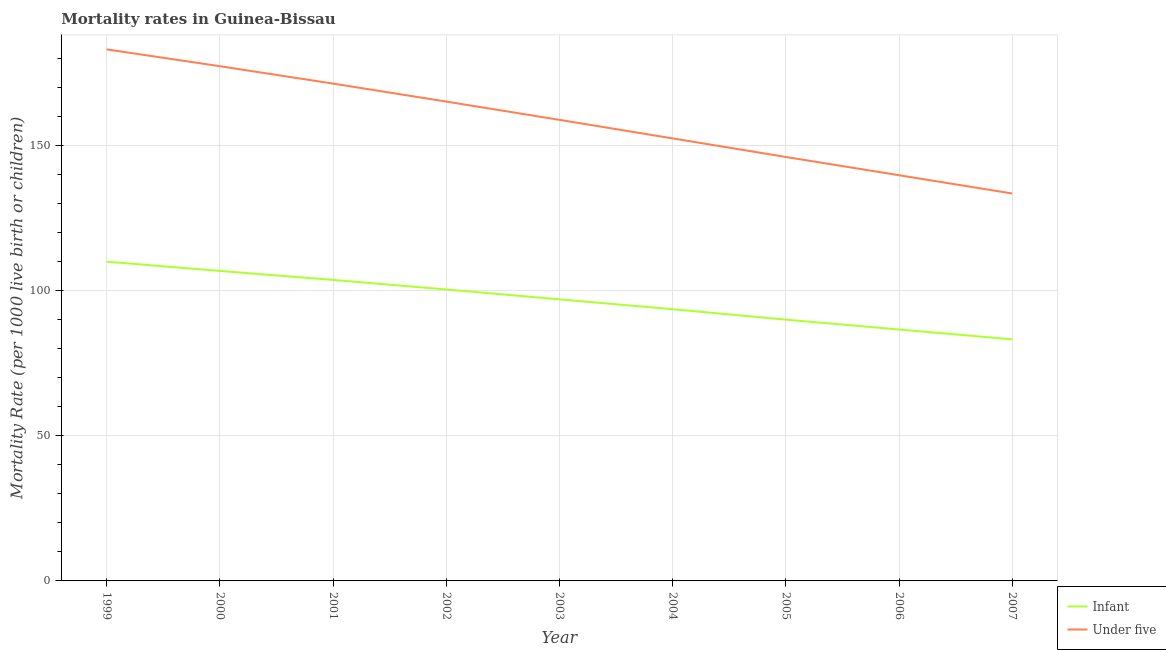How many different coloured lines are there?
Offer a very short reply. 2. Is the number of lines equal to the number of legend labels?
Your answer should be compact. Yes. What is the under-5 mortality rate in 2005?
Ensure brevity in your answer.  146.2. Across all years, what is the maximum under-5 mortality rate?
Give a very brief answer. 183.3. Across all years, what is the minimum infant mortality rate?
Your response must be concise. 83.3. In which year was the infant mortality rate maximum?
Provide a succinct answer. 1999. What is the total under-5 mortality rate in the graph?
Offer a terse response. 1428.9. What is the difference between the under-5 mortality rate in 2002 and that in 2006?
Offer a terse response. 25.4. What is the difference between the under-5 mortality rate in 2003 and the infant mortality rate in 2007?
Offer a terse response. 75.7. What is the average under-5 mortality rate per year?
Ensure brevity in your answer.  158.77. In the year 2002, what is the difference between the infant mortality rate and under-5 mortality rate?
Provide a short and direct response. -64.8. In how many years, is the under-5 mortality rate greater than 160?
Your answer should be compact. 4. What is the ratio of the infant mortality rate in 2001 to that in 2005?
Your answer should be very brief. 1.15. Is the infant mortality rate in 1999 less than that in 2004?
Offer a very short reply. No. What is the difference between the highest and the second highest under-5 mortality rate?
Ensure brevity in your answer.  5.8. What is the difference between the highest and the lowest infant mortality rate?
Keep it short and to the point. 26.8. In how many years, is the under-5 mortality rate greater than the average under-5 mortality rate taken over all years?
Your answer should be compact. 5. Is the sum of the under-5 mortality rate in 1999 and 2003 greater than the maximum infant mortality rate across all years?
Offer a terse response. Yes. Does the infant mortality rate monotonically increase over the years?
Give a very brief answer. No. Is the infant mortality rate strictly less than the under-5 mortality rate over the years?
Your answer should be very brief. Yes. Are the values on the major ticks of Y-axis written in scientific E-notation?
Your answer should be very brief. No. Does the graph contain any zero values?
Offer a terse response. No. Does the graph contain grids?
Make the answer very short. Yes. How many legend labels are there?
Offer a very short reply. 2. What is the title of the graph?
Provide a succinct answer. Mortality rates in Guinea-Bissau. Does "Pregnant women" appear as one of the legend labels in the graph?
Offer a terse response. No. What is the label or title of the Y-axis?
Your answer should be compact. Mortality Rate (per 1000 live birth or children). What is the Mortality Rate (per 1000 live birth or children) of Infant in 1999?
Ensure brevity in your answer.  110.1. What is the Mortality Rate (per 1000 live birth or children) of Under five in 1999?
Ensure brevity in your answer.  183.3. What is the Mortality Rate (per 1000 live birth or children) in Infant in 2000?
Provide a succinct answer. 106.9. What is the Mortality Rate (per 1000 live birth or children) of Under five in 2000?
Make the answer very short. 177.5. What is the Mortality Rate (per 1000 live birth or children) in Infant in 2001?
Offer a very short reply. 103.8. What is the Mortality Rate (per 1000 live birth or children) of Under five in 2001?
Your answer should be compact. 171.5. What is the Mortality Rate (per 1000 live birth or children) of Infant in 2002?
Give a very brief answer. 100.5. What is the Mortality Rate (per 1000 live birth or children) of Under five in 2002?
Your answer should be compact. 165.3. What is the Mortality Rate (per 1000 live birth or children) of Infant in 2003?
Ensure brevity in your answer.  97.1. What is the Mortality Rate (per 1000 live birth or children) in Under five in 2003?
Provide a succinct answer. 159. What is the Mortality Rate (per 1000 live birth or children) of Infant in 2004?
Make the answer very short. 93.7. What is the Mortality Rate (per 1000 live birth or children) in Under five in 2004?
Your response must be concise. 152.6. What is the Mortality Rate (per 1000 live birth or children) of Infant in 2005?
Your answer should be very brief. 90.1. What is the Mortality Rate (per 1000 live birth or children) of Under five in 2005?
Provide a succinct answer. 146.2. What is the Mortality Rate (per 1000 live birth or children) of Infant in 2006?
Make the answer very short. 86.7. What is the Mortality Rate (per 1000 live birth or children) in Under five in 2006?
Offer a terse response. 139.9. What is the Mortality Rate (per 1000 live birth or children) of Infant in 2007?
Offer a terse response. 83.3. What is the Mortality Rate (per 1000 live birth or children) of Under five in 2007?
Make the answer very short. 133.6. Across all years, what is the maximum Mortality Rate (per 1000 live birth or children) in Infant?
Give a very brief answer. 110.1. Across all years, what is the maximum Mortality Rate (per 1000 live birth or children) of Under five?
Your response must be concise. 183.3. Across all years, what is the minimum Mortality Rate (per 1000 live birth or children) in Infant?
Your answer should be compact. 83.3. Across all years, what is the minimum Mortality Rate (per 1000 live birth or children) of Under five?
Offer a very short reply. 133.6. What is the total Mortality Rate (per 1000 live birth or children) in Infant in the graph?
Your answer should be compact. 872.2. What is the total Mortality Rate (per 1000 live birth or children) of Under five in the graph?
Your answer should be very brief. 1428.9. What is the difference between the Mortality Rate (per 1000 live birth or children) in Under five in 1999 and that in 2000?
Your answer should be compact. 5.8. What is the difference between the Mortality Rate (per 1000 live birth or children) in Under five in 1999 and that in 2001?
Provide a succinct answer. 11.8. What is the difference between the Mortality Rate (per 1000 live birth or children) in Under five in 1999 and that in 2003?
Your response must be concise. 24.3. What is the difference between the Mortality Rate (per 1000 live birth or children) in Infant in 1999 and that in 2004?
Provide a short and direct response. 16.4. What is the difference between the Mortality Rate (per 1000 live birth or children) in Under five in 1999 and that in 2004?
Keep it short and to the point. 30.7. What is the difference between the Mortality Rate (per 1000 live birth or children) in Under five in 1999 and that in 2005?
Provide a short and direct response. 37.1. What is the difference between the Mortality Rate (per 1000 live birth or children) of Infant in 1999 and that in 2006?
Ensure brevity in your answer.  23.4. What is the difference between the Mortality Rate (per 1000 live birth or children) of Under five in 1999 and that in 2006?
Provide a short and direct response. 43.4. What is the difference between the Mortality Rate (per 1000 live birth or children) of Infant in 1999 and that in 2007?
Your answer should be very brief. 26.8. What is the difference between the Mortality Rate (per 1000 live birth or children) in Under five in 1999 and that in 2007?
Offer a terse response. 49.7. What is the difference between the Mortality Rate (per 1000 live birth or children) of Under five in 2000 and that in 2001?
Offer a very short reply. 6. What is the difference between the Mortality Rate (per 1000 live birth or children) of Infant in 2000 and that in 2003?
Offer a terse response. 9.8. What is the difference between the Mortality Rate (per 1000 live birth or children) in Infant in 2000 and that in 2004?
Keep it short and to the point. 13.2. What is the difference between the Mortality Rate (per 1000 live birth or children) of Under five in 2000 and that in 2004?
Give a very brief answer. 24.9. What is the difference between the Mortality Rate (per 1000 live birth or children) of Infant in 2000 and that in 2005?
Ensure brevity in your answer.  16.8. What is the difference between the Mortality Rate (per 1000 live birth or children) in Under five in 2000 and that in 2005?
Your response must be concise. 31.3. What is the difference between the Mortality Rate (per 1000 live birth or children) in Infant in 2000 and that in 2006?
Offer a very short reply. 20.2. What is the difference between the Mortality Rate (per 1000 live birth or children) in Under five in 2000 and that in 2006?
Give a very brief answer. 37.6. What is the difference between the Mortality Rate (per 1000 live birth or children) of Infant in 2000 and that in 2007?
Provide a short and direct response. 23.6. What is the difference between the Mortality Rate (per 1000 live birth or children) of Under five in 2000 and that in 2007?
Keep it short and to the point. 43.9. What is the difference between the Mortality Rate (per 1000 live birth or children) of Under five in 2001 and that in 2002?
Your answer should be very brief. 6.2. What is the difference between the Mortality Rate (per 1000 live birth or children) in Infant in 2001 and that in 2003?
Provide a succinct answer. 6.7. What is the difference between the Mortality Rate (per 1000 live birth or children) of Under five in 2001 and that in 2004?
Keep it short and to the point. 18.9. What is the difference between the Mortality Rate (per 1000 live birth or children) of Infant in 2001 and that in 2005?
Offer a very short reply. 13.7. What is the difference between the Mortality Rate (per 1000 live birth or children) of Under five in 2001 and that in 2005?
Your answer should be very brief. 25.3. What is the difference between the Mortality Rate (per 1000 live birth or children) in Under five in 2001 and that in 2006?
Your answer should be very brief. 31.6. What is the difference between the Mortality Rate (per 1000 live birth or children) of Under five in 2001 and that in 2007?
Ensure brevity in your answer.  37.9. What is the difference between the Mortality Rate (per 1000 live birth or children) of Infant in 2002 and that in 2003?
Your answer should be very brief. 3.4. What is the difference between the Mortality Rate (per 1000 live birth or children) in Under five in 2002 and that in 2003?
Your response must be concise. 6.3. What is the difference between the Mortality Rate (per 1000 live birth or children) in Under five in 2002 and that in 2005?
Provide a succinct answer. 19.1. What is the difference between the Mortality Rate (per 1000 live birth or children) in Under five in 2002 and that in 2006?
Keep it short and to the point. 25.4. What is the difference between the Mortality Rate (per 1000 live birth or children) of Infant in 2002 and that in 2007?
Your answer should be compact. 17.2. What is the difference between the Mortality Rate (per 1000 live birth or children) of Under five in 2002 and that in 2007?
Provide a succinct answer. 31.7. What is the difference between the Mortality Rate (per 1000 live birth or children) of Under five in 2003 and that in 2004?
Your response must be concise. 6.4. What is the difference between the Mortality Rate (per 1000 live birth or children) of Infant in 2003 and that in 2005?
Keep it short and to the point. 7. What is the difference between the Mortality Rate (per 1000 live birth or children) in Under five in 2003 and that in 2005?
Give a very brief answer. 12.8. What is the difference between the Mortality Rate (per 1000 live birth or children) of Infant in 2003 and that in 2006?
Make the answer very short. 10.4. What is the difference between the Mortality Rate (per 1000 live birth or children) of Infant in 2003 and that in 2007?
Offer a very short reply. 13.8. What is the difference between the Mortality Rate (per 1000 live birth or children) of Under five in 2003 and that in 2007?
Ensure brevity in your answer.  25.4. What is the difference between the Mortality Rate (per 1000 live birth or children) in Under five in 2004 and that in 2005?
Make the answer very short. 6.4. What is the difference between the Mortality Rate (per 1000 live birth or children) of Infant in 2004 and that in 2006?
Keep it short and to the point. 7. What is the difference between the Mortality Rate (per 1000 live birth or children) in Under five in 2004 and that in 2006?
Keep it short and to the point. 12.7. What is the difference between the Mortality Rate (per 1000 live birth or children) of Infant in 2004 and that in 2007?
Ensure brevity in your answer.  10.4. What is the difference between the Mortality Rate (per 1000 live birth or children) in Under five in 2006 and that in 2007?
Provide a short and direct response. 6.3. What is the difference between the Mortality Rate (per 1000 live birth or children) in Infant in 1999 and the Mortality Rate (per 1000 live birth or children) in Under five in 2000?
Your response must be concise. -67.4. What is the difference between the Mortality Rate (per 1000 live birth or children) of Infant in 1999 and the Mortality Rate (per 1000 live birth or children) of Under five in 2001?
Provide a succinct answer. -61.4. What is the difference between the Mortality Rate (per 1000 live birth or children) of Infant in 1999 and the Mortality Rate (per 1000 live birth or children) of Under five in 2002?
Provide a short and direct response. -55.2. What is the difference between the Mortality Rate (per 1000 live birth or children) of Infant in 1999 and the Mortality Rate (per 1000 live birth or children) of Under five in 2003?
Ensure brevity in your answer.  -48.9. What is the difference between the Mortality Rate (per 1000 live birth or children) in Infant in 1999 and the Mortality Rate (per 1000 live birth or children) in Under five in 2004?
Offer a terse response. -42.5. What is the difference between the Mortality Rate (per 1000 live birth or children) of Infant in 1999 and the Mortality Rate (per 1000 live birth or children) of Under five in 2005?
Provide a short and direct response. -36.1. What is the difference between the Mortality Rate (per 1000 live birth or children) of Infant in 1999 and the Mortality Rate (per 1000 live birth or children) of Under five in 2006?
Keep it short and to the point. -29.8. What is the difference between the Mortality Rate (per 1000 live birth or children) of Infant in 1999 and the Mortality Rate (per 1000 live birth or children) of Under five in 2007?
Offer a very short reply. -23.5. What is the difference between the Mortality Rate (per 1000 live birth or children) in Infant in 2000 and the Mortality Rate (per 1000 live birth or children) in Under five in 2001?
Your response must be concise. -64.6. What is the difference between the Mortality Rate (per 1000 live birth or children) of Infant in 2000 and the Mortality Rate (per 1000 live birth or children) of Under five in 2002?
Your answer should be very brief. -58.4. What is the difference between the Mortality Rate (per 1000 live birth or children) in Infant in 2000 and the Mortality Rate (per 1000 live birth or children) in Under five in 2003?
Provide a succinct answer. -52.1. What is the difference between the Mortality Rate (per 1000 live birth or children) in Infant in 2000 and the Mortality Rate (per 1000 live birth or children) in Under five in 2004?
Your response must be concise. -45.7. What is the difference between the Mortality Rate (per 1000 live birth or children) of Infant in 2000 and the Mortality Rate (per 1000 live birth or children) of Under five in 2005?
Your answer should be very brief. -39.3. What is the difference between the Mortality Rate (per 1000 live birth or children) of Infant in 2000 and the Mortality Rate (per 1000 live birth or children) of Under five in 2006?
Your response must be concise. -33. What is the difference between the Mortality Rate (per 1000 live birth or children) of Infant in 2000 and the Mortality Rate (per 1000 live birth or children) of Under five in 2007?
Ensure brevity in your answer.  -26.7. What is the difference between the Mortality Rate (per 1000 live birth or children) of Infant in 2001 and the Mortality Rate (per 1000 live birth or children) of Under five in 2002?
Ensure brevity in your answer.  -61.5. What is the difference between the Mortality Rate (per 1000 live birth or children) in Infant in 2001 and the Mortality Rate (per 1000 live birth or children) in Under five in 2003?
Ensure brevity in your answer.  -55.2. What is the difference between the Mortality Rate (per 1000 live birth or children) of Infant in 2001 and the Mortality Rate (per 1000 live birth or children) of Under five in 2004?
Keep it short and to the point. -48.8. What is the difference between the Mortality Rate (per 1000 live birth or children) of Infant in 2001 and the Mortality Rate (per 1000 live birth or children) of Under five in 2005?
Your answer should be compact. -42.4. What is the difference between the Mortality Rate (per 1000 live birth or children) in Infant in 2001 and the Mortality Rate (per 1000 live birth or children) in Under five in 2006?
Your answer should be compact. -36.1. What is the difference between the Mortality Rate (per 1000 live birth or children) in Infant in 2001 and the Mortality Rate (per 1000 live birth or children) in Under five in 2007?
Offer a very short reply. -29.8. What is the difference between the Mortality Rate (per 1000 live birth or children) of Infant in 2002 and the Mortality Rate (per 1000 live birth or children) of Under five in 2003?
Offer a terse response. -58.5. What is the difference between the Mortality Rate (per 1000 live birth or children) of Infant in 2002 and the Mortality Rate (per 1000 live birth or children) of Under five in 2004?
Keep it short and to the point. -52.1. What is the difference between the Mortality Rate (per 1000 live birth or children) of Infant in 2002 and the Mortality Rate (per 1000 live birth or children) of Under five in 2005?
Keep it short and to the point. -45.7. What is the difference between the Mortality Rate (per 1000 live birth or children) in Infant in 2002 and the Mortality Rate (per 1000 live birth or children) in Under five in 2006?
Provide a succinct answer. -39.4. What is the difference between the Mortality Rate (per 1000 live birth or children) in Infant in 2002 and the Mortality Rate (per 1000 live birth or children) in Under five in 2007?
Offer a very short reply. -33.1. What is the difference between the Mortality Rate (per 1000 live birth or children) in Infant in 2003 and the Mortality Rate (per 1000 live birth or children) in Under five in 2004?
Provide a short and direct response. -55.5. What is the difference between the Mortality Rate (per 1000 live birth or children) of Infant in 2003 and the Mortality Rate (per 1000 live birth or children) of Under five in 2005?
Your response must be concise. -49.1. What is the difference between the Mortality Rate (per 1000 live birth or children) of Infant in 2003 and the Mortality Rate (per 1000 live birth or children) of Under five in 2006?
Your response must be concise. -42.8. What is the difference between the Mortality Rate (per 1000 live birth or children) in Infant in 2003 and the Mortality Rate (per 1000 live birth or children) in Under five in 2007?
Ensure brevity in your answer.  -36.5. What is the difference between the Mortality Rate (per 1000 live birth or children) of Infant in 2004 and the Mortality Rate (per 1000 live birth or children) of Under five in 2005?
Keep it short and to the point. -52.5. What is the difference between the Mortality Rate (per 1000 live birth or children) of Infant in 2004 and the Mortality Rate (per 1000 live birth or children) of Under five in 2006?
Give a very brief answer. -46.2. What is the difference between the Mortality Rate (per 1000 live birth or children) in Infant in 2004 and the Mortality Rate (per 1000 live birth or children) in Under five in 2007?
Make the answer very short. -39.9. What is the difference between the Mortality Rate (per 1000 live birth or children) of Infant in 2005 and the Mortality Rate (per 1000 live birth or children) of Under five in 2006?
Your answer should be compact. -49.8. What is the difference between the Mortality Rate (per 1000 live birth or children) in Infant in 2005 and the Mortality Rate (per 1000 live birth or children) in Under five in 2007?
Offer a terse response. -43.5. What is the difference between the Mortality Rate (per 1000 live birth or children) of Infant in 2006 and the Mortality Rate (per 1000 live birth or children) of Under five in 2007?
Keep it short and to the point. -46.9. What is the average Mortality Rate (per 1000 live birth or children) of Infant per year?
Give a very brief answer. 96.91. What is the average Mortality Rate (per 1000 live birth or children) in Under five per year?
Your response must be concise. 158.77. In the year 1999, what is the difference between the Mortality Rate (per 1000 live birth or children) in Infant and Mortality Rate (per 1000 live birth or children) in Under five?
Provide a succinct answer. -73.2. In the year 2000, what is the difference between the Mortality Rate (per 1000 live birth or children) in Infant and Mortality Rate (per 1000 live birth or children) in Under five?
Provide a short and direct response. -70.6. In the year 2001, what is the difference between the Mortality Rate (per 1000 live birth or children) in Infant and Mortality Rate (per 1000 live birth or children) in Under five?
Make the answer very short. -67.7. In the year 2002, what is the difference between the Mortality Rate (per 1000 live birth or children) in Infant and Mortality Rate (per 1000 live birth or children) in Under five?
Your response must be concise. -64.8. In the year 2003, what is the difference between the Mortality Rate (per 1000 live birth or children) of Infant and Mortality Rate (per 1000 live birth or children) of Under five?
Give a very brief answer. -61.9. In the year 2004, what is the difference between the Mortality Rate (per 1000 live birth or children) of Infant and Mortality Rate (per 1000 live birth or children) of Under five?
Your response must be concise. -58.9. In the year 2005, what is the difference between the Mortality Rate (per 1000 live birth or children) of Infant and Mortality Rate (per 1000 live birth or children) of Under five?
Make the answer very short. -56.1. In the year 2006, what is the difference between the Mortality Rate (per 1000 live birth or children) in Infant and Mortality Rate (per 1000 live birth or children) in Under five?
Offer a very short reply. -53.2. In the year 2007, what is the difference between the Mortality Rate (per 1000 live birth or children) of Infant and Mortality Rate (per 1000 live birth or children) of Under five?
Make the answer very short. -50.3. What is the ratio of the Mortality Rate (per 1000 live birth or children) in Infant in 1999 to that in 2000?
Your answer should be very brief. 1.03. What is the ratio of the Mortality Rate (per 1000 live birth or children) in Under five in 1999 to that in 2000?
Provide a short and direct response. 1.03. What is the ratio of the Mortality Rate (per 1000 live birth or children) of Infant in 1999 to that in 2001?
Offer a terse response. 1.06. What is the ratio of the Mortality Rate (per 1000 live birth or children) of Under five in 1999 to that in 2001?
Offer a terse response. 1.07. What is the ratio of the Mortality Rate (per 1000 live birth or children) of Infant in 1999 to that in 2002?
Ensure brevity in your answer.  1.1. What is the ratio of the Mortality Rate (per 1000 live birth or children) in Under five in 1999 to that in 2002?
Make the answer very short. 1.11. What is the ratio of the Mortality Rate (per 1000 live birth or children) in Infant in 1999 to that in 2003?
Your response must be concise. 1.13. What is the ratio of the Mortality Rate (per 1000 live birth or children) of Under five in 1999 to that in 2003?
Your response must be concise. 1.15. What is the ratio of the Mortality Rate (per 1000 live birth or children) in Infant in 1999 to that in 2004?
Provide a succinct answer. 1.18. What is the ratio of the Mortality Rate (per 1000 live birth or children) in Under five in 1999 to that in 2004?
Your answer should be very brief. 1.2. What is the ratio of the Mortality Rate (per 1000 live birth or children) of Infant in 1999 to that in 2005?
Keep it short and to the point. 1.22. What is the ratio of the Mortality Rate (per 1000 live birth or children) of Under five in 1999 to that in 2005?
Provide a succinct answer. 1.25. What is the ratio of the Mortality Rate (per 1000 live birth or children) of Infant in 1999 to that in 2006?
Give a very brief answer. 1.27. What is the ratio of the Mortality Rate (per 1000 live birth or children) in Under five in 1999 to that in 2006?
Offer a very short reply. 1.31. What is the ratio of the Mortality Rate (per 1000 live birth or children) of Infant in 1999 to that in 2007?
Your answer should be compact. 1.32. What is the ratio of the Mortality Rate (per 1000 live birth or children) of Under five in 1999 to that in 2007?
Give a very brief answer. 1.37. What is the ratio of the Mortality Rate (per 1000 live birth or children) of Infant in 2000 to that in 2001?
Offer a terse response. 1.03. What is the ratio of the Mortality Rate (per 1000 live birth or children) in Under five in 2000 to that in 2001?
Your answer should be compact. 1.03. What is the ratio of the Mortality Rate (per 1000 live birth or children) in Infant in 2000 to that in 2002?
Provide a short and direct response. 1.06. What is the ratio of the Mortality Rate (per 1000 live birth or children) of Under five in 2000 to that in 2002?
Make the answer very short. 1.07. What is the ratio of the Mortality Rate (per 1000 live birth or children) of Infant in 2000 to that in 2003?
Your answer should be compact. 1.1. What is the ratio of the Mortality Rate (per 1000 live birth or children) in Under five in 2000 to that in 2003?
Your answer should be very brief. 1.12. What is the ratio of the Mortality Rate (per 1000 live birth or children) in Infant in 2000 to that in 2004?
Keep it short and to the point. 1.14. What is the ratio of the Mortality Rate (per 1000 live birth or children) in Under five in 2000 to that in 2004?
Provide a succinct answer. 1.16. What is the ratio of the Mortality Rate (per 1000 live birth or children) of Infant in 2000 to that in 2005?
Your answer should be very brief. 1.19. What is the ratio of the Mortality Rate (per 1000 live birth or children) in Under five in 2000 to that in 2005?
Ensure brevity in your answer.  1.21. What is the ratio of the Mortality Rate (per 1000 live birth or children) in Infant in 2000 to that in 2006?
Your answer should be compact. 1.23. What is the ratio of the Mortality Rate (per 1000 live birth or children) in Under five in 2000 to that in 2006?
Ensure brevity in your answer.  1.27. What is the ratio of the Mortality Rate (per 1000 live birth or children) of Infant in 2000 to that in 2007?
Ensure brevity in your answer.  1.28. What is the ratio of the Mortality Rate (per 1000 live birth or children) of Under five in 2000 to that in 2007?
Ensure brevity in your answer.  1.33. What is the ratio of the Mortality Rate (per 1000 live birth or children) in Infant in 2001 to that in 2002?
Offer a terse response. 1.03. What is the ratio of the Mortality Rate (per 1000 live birth or children) of Under five in 2001 to that in 2002?
Keep it short and to the point. 1.04. What is the ratio of the Mortality Rate (per 1000 live birth or children) of Infant in 2001 to that in 2003?
Provide a short and direct response. 1.07. What is the ratio of the Mortality Rate (per 1000 live birth or children) of Under five in 2001 to that in 2003?
Your answer should be compact. 1.08. What is the ratio of the Mortality Rate (per 1000 live birth or children) in Infant in 2001 to that in 2004?
Offer a terse response. 1.11. What is the ratio of the Mortality Rate (per 1000 live birth or children) of Under five in 2001 to that in 2004?
Offer a very short reply. 1.12. What is the ratio of the Mortality Rate (per 1000 live birth or children) in Infant in 2001 to that in 2005?
Give a very brief answer. 1.15. What is the ratio of the Mortality Rate (per 1000 live birth or children) of Under five in 2001 to that in 2005?
Keep it short and to the point. 1.17. What is the ratio of the Mortality Rate (per 1000 live birth or children) in Infant in 2001 to that in 2006?
Give a very brief answer. 1.2. What is the ratio of the Mortality Rate (per 1000 live birth or children) in Under five in 2001 to that in 2006?
Give a very brief answer. 1.23. What is the ratio of the Mortality Rate (per 1000 live birth or children) in Infant in 2001 to that in 2007?
Make the answer very short. 1.25. What is the ratio of the Mortality Rate (per 1000 live birth or children) of Under five in 2001 to that in 2007?
Make the answer very short. 1.28. What is the ratio of the Mortality Rate (per 1000 live birth or children) of Infant in 2002 to that in 2003?
Your response must be concise. 1.03. What is the ratio of the Mortality Rate (per 1000 live birth or children) in Under five in 2002 to that in 2003?
Offer a very short reply. 1.04. What is the ratio of the Mortality Rate (per 1000 live birth or children) in Infant in 2002 to that in 2004?
Provide a short and direct response. 1.07. What is the ratio of the Mortality Rate (per 1000 live birth or children) in Under five in 2002 to that in 2004?
Offer a very short reply. 1.08. What is the ratio of the Mortality Rate (per 1000 live birth or children) of Infant in 2002 to that in 2005?
Provide a short and direct response. 1.12. What is the ratio of the Mortality Rate (per 1000 live birth or children) of Under five in 2002 to that in 2005?
Provide a short and direct response. 1.13. What is the ratio of the Mortality Rate (per 1000 live birth or children) in Infant in 2002 to that in 2006?
Make the answer very short. 1.16. What is the ratio of the Mortality Rate (per 1000 live birth or children) in Under five in 2002 to that in 2006?
Offer a very short reply. 1.18. What is the ratio of the Mortality Rate (per 1000 live birth or children) of Infant in 2002 to that in 2007?
Provide a succinct answer. 1.21. What is the ratio of the Mortality Rate (per 1000 live birth or children) in Under five in 2002 to that in 2007?
Your answer should be very brief. 1.24. What is the ratio of the Mortality Rate (per 1000 live birth or children) in Infant in 2003 to that in 2004?
Make the answer very short. 1.04. What is the ratio of the Mortality Rate (per 1000 live birth or children) of Under five in 2003 to that in 2004?
Provide a short and direct response. 1.04. What is the ratio of the Mortality Rate (per 1000 live birth or children) in Infant in 2003 to that in 2005?
Your answer should be compact. 1.08. What is the ratio of the Mortality Rate (per 1000 live birth or children) of Under five in 2003 to that in 2005?
Your answer should be compact. 1.09. What is the ratio of the Mortality Rate (per 1000 live birth or children) of Infant in 2003 to that in 2006?
Offer a very short reply. 1.12. What is the ratio of the Mortality Rate (per 1000 live birth or children) of Under five in 2003 to that in 2006?
Your answer should be compact. 1.14. What is the ratio of the Mortality Rate (per 1000 live birth or children) in Infant in 2003 to that in 2007?
Offer a very short reply. 1.17. What is the ratio of the Mortality Rate (per 1000 live birth or children) in Under five in 2003 to that in 2007?
Offer a very short reply. 1.19. What is the ratio of the Mortality Rate (per 1000 live birth or children) in Under five in 2004 to that in 2005?
Ensure brevity in your answer.  1.04. What is the ratio of the Mortality Rate (per 1000 live birth or children) in Infant in 2004 to that in 2006?
Give a very brief answer. 1.08. What is the ratio of the Mortality Rate (per 1000 live birth or children) of Under five in 2004 to that in 2006?
Your answer should be compact. 1.09. What is the ratio of the Mortality Rate (per 1000 live birth or children) in Infant in 2004 to that in 2007?
Provide a succinct answer. 1.12. What is the ratio of the Mortality Rate (per 1000 live birth or children) in Under five in 2004 to that in 2007?
Offer a terse response. 1.14. What is the ratio of the Mortality Rate (per 1000 live birth or children) of Infant in 2005 to that in 2006?
Offer a very short reply. 1.04. What is the ratio of the Mortality Rate (per 1000 live birth or children) in Under five in 2005 to that in 2006?
Your answer should be compact. 1.04. What is the ratio of the Mortality Rate (per 1000 live birth or children) in Infant in 2005 to that in 2007?
Ensure brevity in your answer.  1.08. What is the ratio of the Mortality Rate (per 1000 live birth or children) in Under five in 2005 to that in 2007?
Offer a very short reply. 1.09. What is the ratio of the Mortality Rate (per 1000 live birth or children) in Infant in 2006 to that in 2007?
Offer a terse response. 1.04. What is the ratio of the Mortality Rate (per 1000 live birth or children) of Under five in 2006 to that in 2007?
Provide a short and direct response. 1.05. What is the difference between the highest and the lowest Mortality Rate (per 1000 live birth or children) in Infant?
Offer a terse response. 26.8. What is the difference between the highest and the lowest Mortality Rate (per 1000 live birth or children) in Under five?
Your response must be concise. 49.7. 